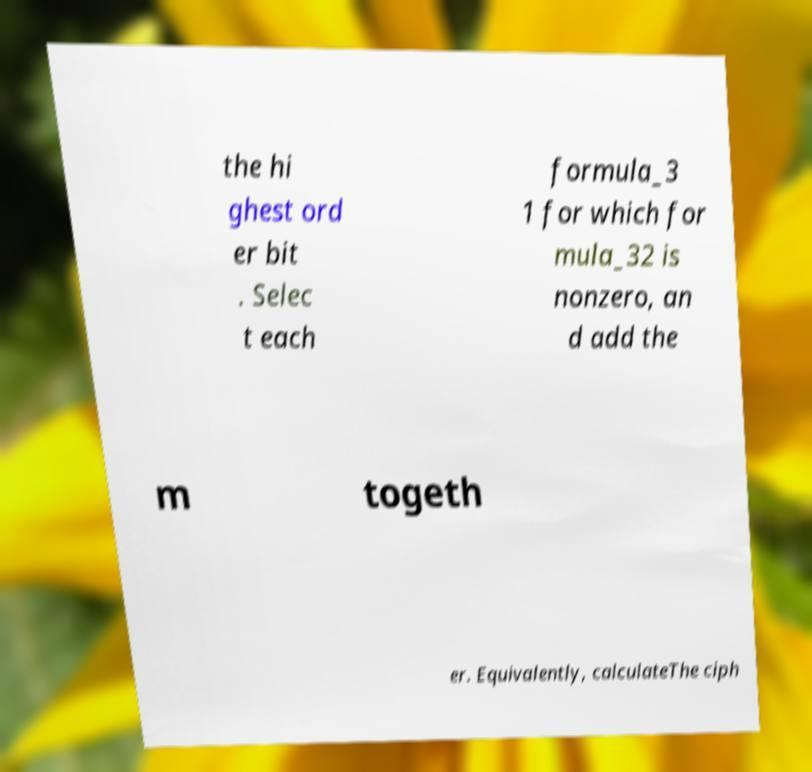Please read and relay the text visible in this image. What does it say? the hi ghest ord er bit . Selec t each formula_3 1 for which for mula_32 is nonzero, an d add the m togeth er. Equivalently, calculateThe ciph 